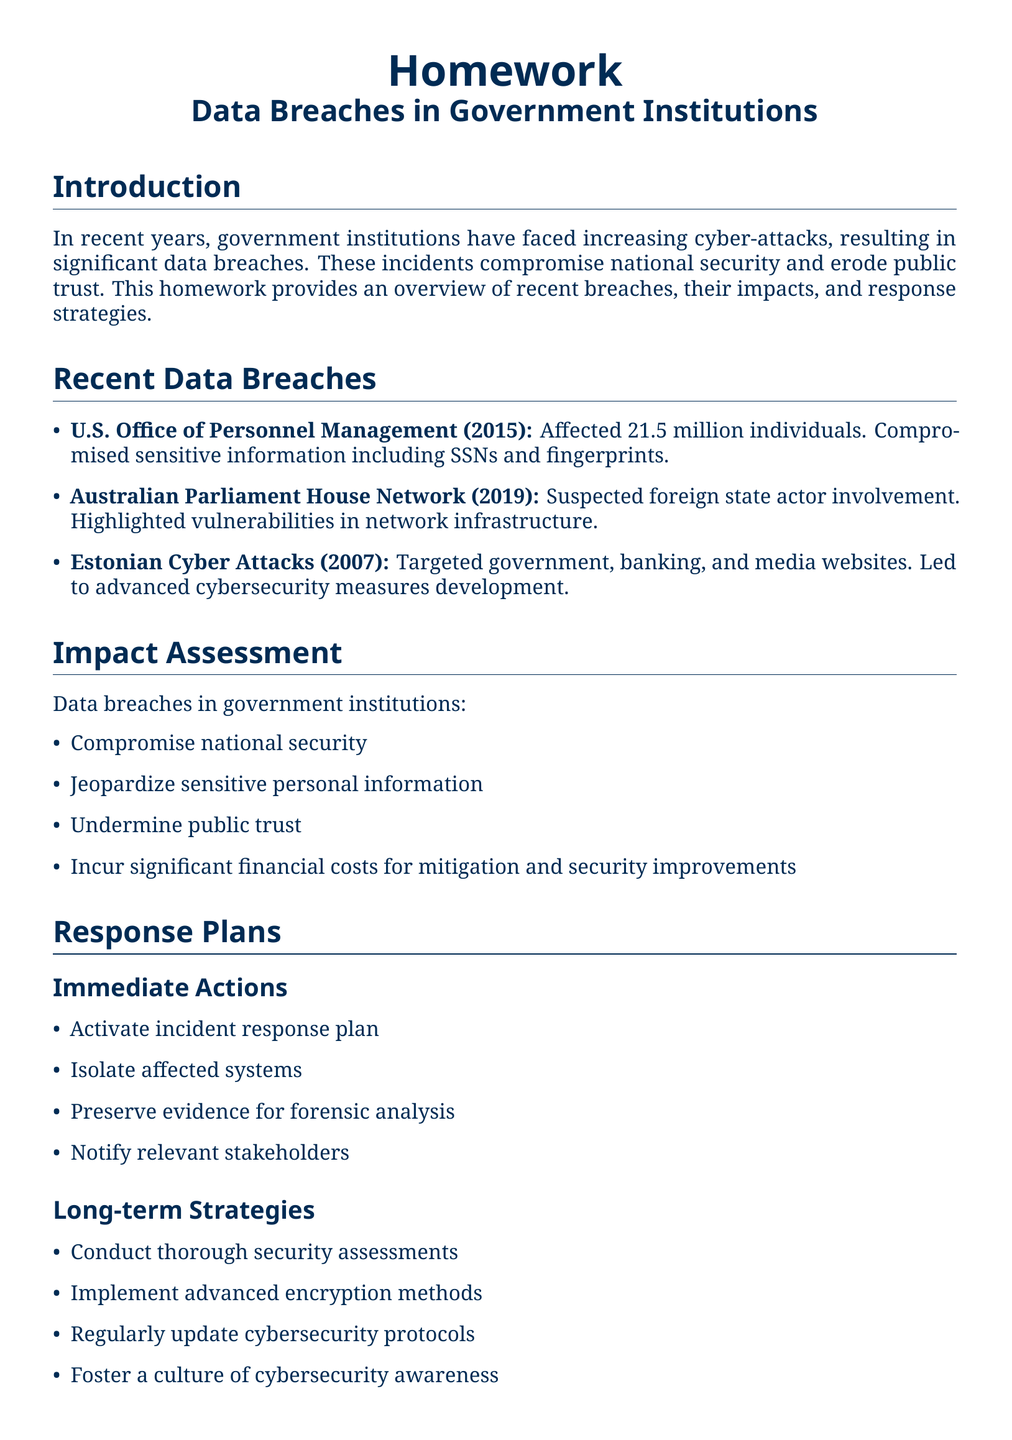What was the year of the U.S. Office of Personnel Management breach? The document lists the year for the U.S. Office of Personnel Management breach as 2015.
Answer: 2015 How many individuals were affected by the U.S. Office of Personnel Management breach? The document states that the breach affected 21.5 million individuals.
Answer: 21.5 million What was the suspected involvement in the Australian Parliament House Network breach? The document indicates suspected foreign state actor involvement in the Australian Parliament House Network breach.
Answer: foreign state actor What is one key consequence of data breaches in government institutions? The document lists several consequences, one of which is compromising national security.
Answer: compromising national security What immediate action must be taken according to the response plans? According to the response plans, one immediate action is to activate the incident response plan.
Answer: activate incident response plan What is a long-term strategy mentioned in the document? The document mentions conducting thorough security assessments as a long-term strategy.
Answer: conducting thorough security assessments Which organizations should be engaged for collaboration and information sharing? The document lists organizations like NCSC (UK) and DHS (US) for collaboration and information sharing.
Answer: NCSC (UK) and DHS (US) What impact does a data breach have on public trust? The document states that breaches undermine public trust.
Answer: undermine public trust 